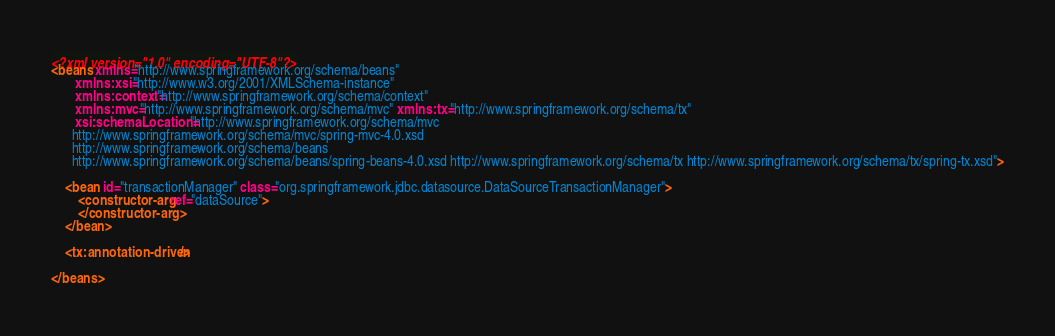<code> <loc_0><loc_0><loc_500><loc_500><_XML_><?xml version="1.0" encoding="UTF-8"?>
<beans xmlns="http://www.springframework.org/schema/beans"
       xmlns:xsi="http://www.w3.org/2001/XMLSchema-instance"
       xmlns:context="http://www.springframework.org/schema/context"
       xmlns:mvc="http://www.springframework.org/schema/mvc" xmlns:tx="http://www.springframework.org/schema/tx"
       xsi:schemaLocation="http://www.springframework.org/schema/mvc
      http://www.springframework.org/schema/mvc/spring-mvc-4.0.xsd
      http://www.springframework.org/schema/beans
      http://www.springframework.org/schema/beans/spring-beans-4.0.xsd http://www.springframework.org/schema/tx http://www.springframework.org/schema/tx/spring-tx.xsd">

    <bean id="transactionManager" class="org.springframework.jdbc.datasource.DataSourceTransactionManager">
        <constructor-arg ref="dataSource">
        </constructor-arg>
    </bean>

    <tx:annotation-driven/>

</beans></code> 